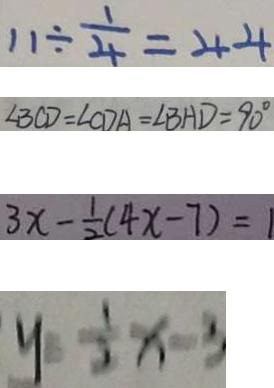<formula> <loc_0><loc_0><loc_500><loc_500>1 1 \div \frac { 1 } { 4 } = 4 4 
 \angle B C D = \angle C D A = \angle B H D = 9 0 ^ { \circ } 
 3 x - \frac { 1 } { 2 } ( 4 x - 7 ) = 1 
 y = \frac { 1 } { 2 } x - 3</formula> 